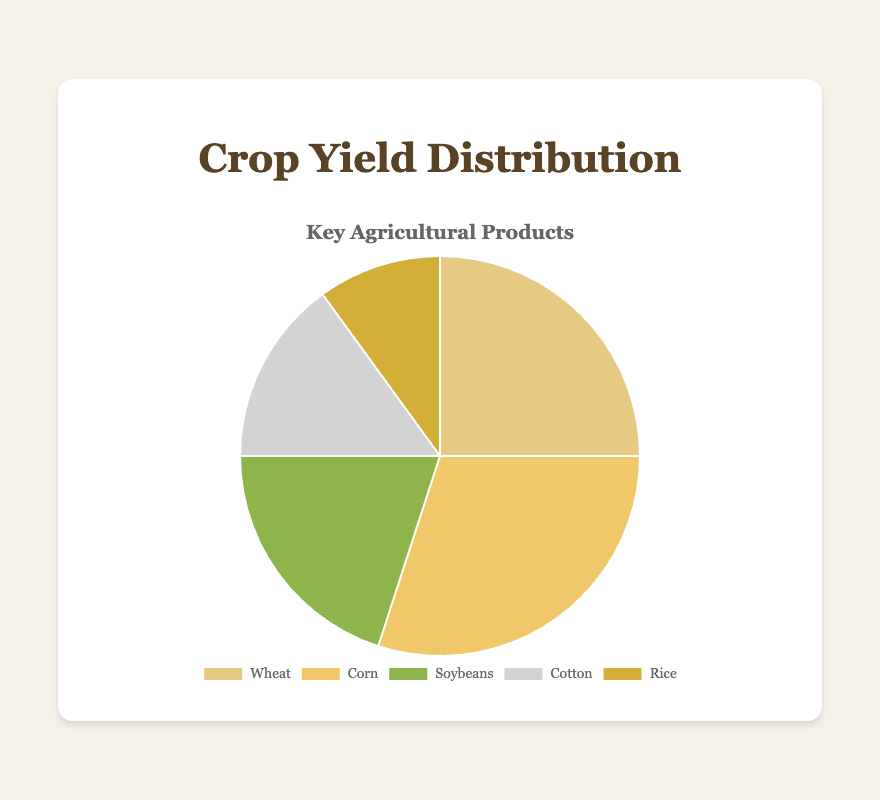What percentage of the crop yield does wheat represent? Wheat represents 25% of the crop yield, directly stated in the data.
Answer: 25% Which crop has the highest yield percentage? Corn has the highest yield percentage, which is 30%, as indicated on the chart.
Answer: Corn What's the combined yield percentage of soybeans and cotton? Add the yield percentages of soybeans (20%) and cotton (15%). Thus, 20% + 15% = 35%.
Answer: 35% Is the yield percentage of rice greater than or less than the yield percentage of cotton? The yield percentage of rice is 10%, which is less than the yield percentage of cotton at 15%.
Answer: Less than Which crop has the smallest yield percentage and what is it? From the data, rice has the smallest yield percentage at 10%.
Answer: Rice, 10% What is the difference between the highest and lowest yield percentages? The highest yield percentage is 30% (Corn) and the lowest is 10% (Rice). So, the difference is 30% - 10% = 20%.
Answer: 20% What's the total yield percentage for key agricultural products representing more than 20% of the yield? Crops representing more than 20% yield are wheat (25%) and corn (30%). The total yield percentage is 25% + 30% = 55%.
Answer: 55% Among wheat, corn, and soybeans, which crop has the middle (median) yield percentage? Wheat (25%), Corn (30%), and Soybeans (20%) have yield percentages. The middle value is 25% (Wheat).
Answer: Wheat How does the yield percentage of corn compare to the combined yield percentage of cotton and rice? Corn's yield percentage is 30%. The combined yield percentage of cotton (15%) and rice (10%) is 15% + 10% = 25%. So, 30% is greater than 25%.
Answer: Greater than Which crops together contribute exactly half (50%) of the total yield percentage? Adding Corn (30%) and Soybeans (20%) yield percentages gives 30% + 20% = 50%.
Answer: Corn and Soybeans 